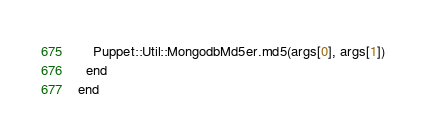<code> <loc_0><loc_0><loc_500><loc_500><_Ruby_>    Puppet::Util::MongodbMd5er.md5(args[0], args[1])
  end
end
</code> 